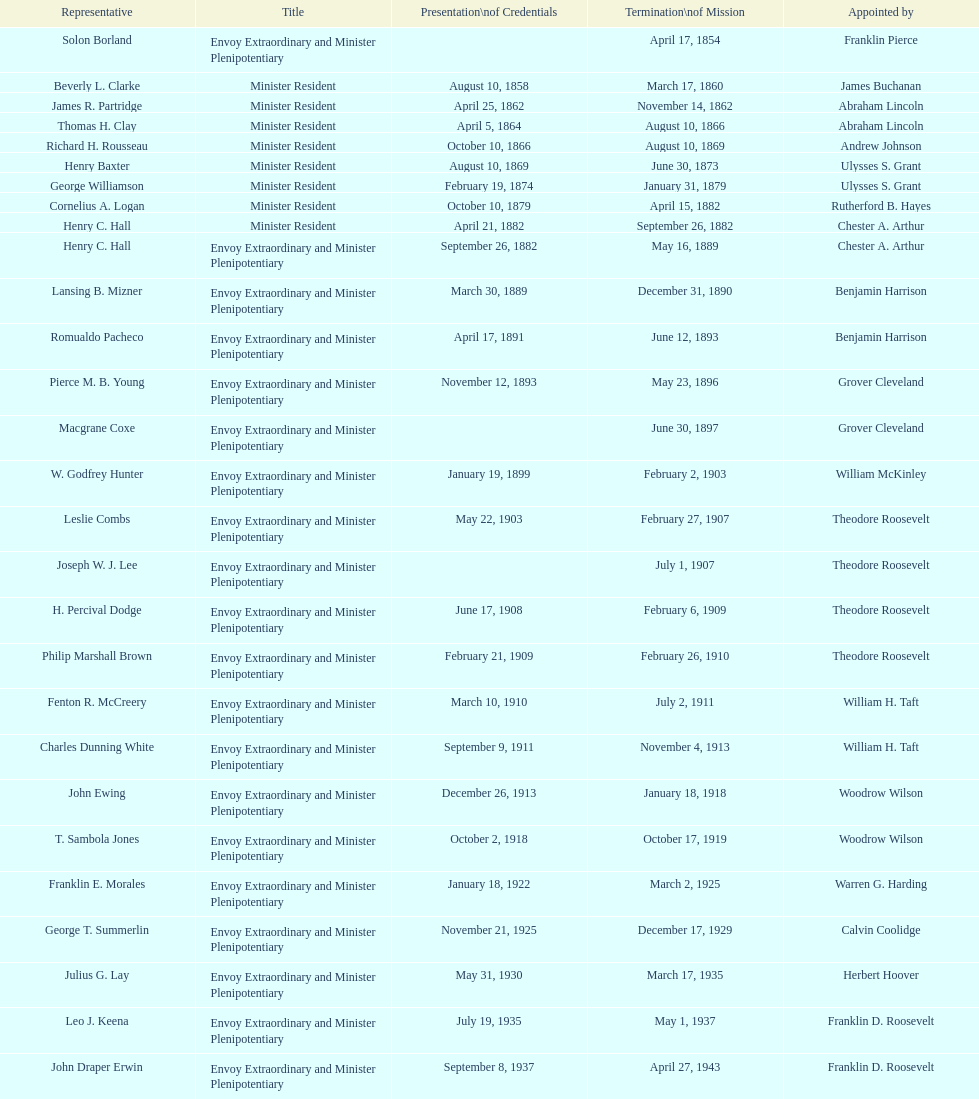Which reps were only appointed by franklin pierce? Solon Borland. 